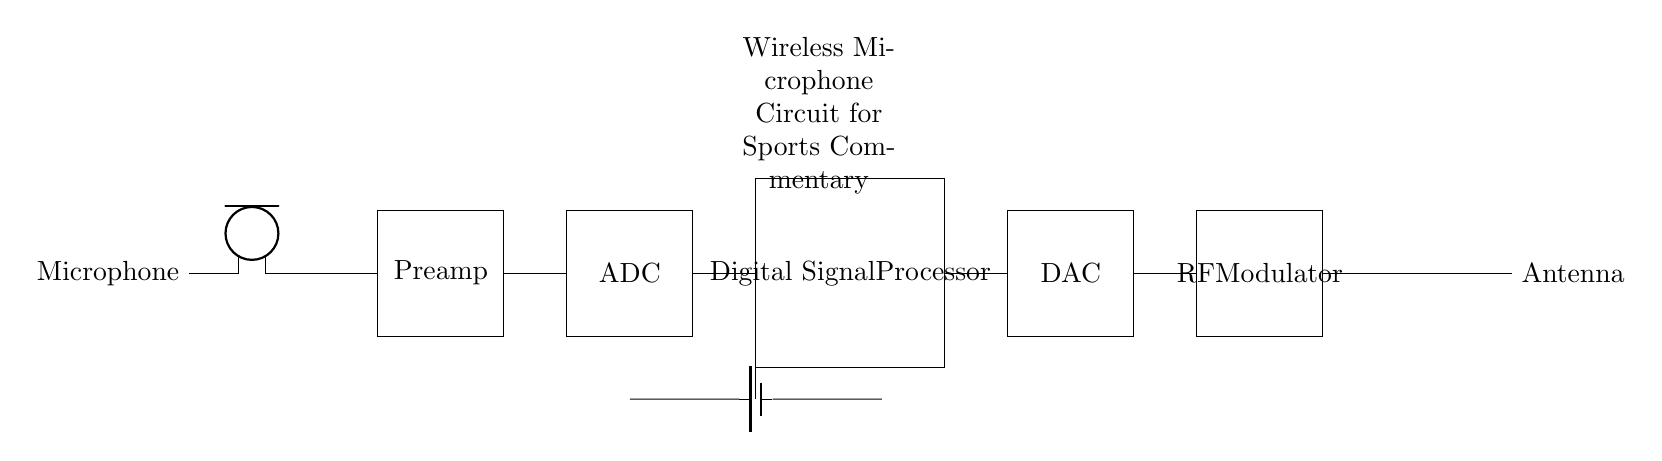What is the first component in the circuit? The first component is the microphone, as it is located at the very beginning of the connection chain, indicating it captures sound.
Answer: Microphone What does the preamp do? The preamp amplifies the weak audio signal from the microphone before it is processed further; it is denoted as a block in the diagram.
Answer: Amplifies How many main processing components are in this circuit? There are four main processing components: Preamp, ADC, Digital Signal Processor, and DAC.
Answer: Four Which component converts analog signals to digital? The ADC (Analog to Digital Converter) is responsible for converting the analog audio signals into digital format for processing.
Answer: ADC What is the purpose of the RF modulator? The RF modulator converts the processed digital signals into radio frequency signals for wireless transmission, indicated by its placement in the circuit.
Answer: Wireless transmission What component is directly connected to the power supply? The Digital Signal Processor is directly connected to the power supply which provides the necessary voltage for operation, as illustrated in the circuit.
Answer: Digital Signal Processor Which component is responsible for sending the signal out? The antenna is responsible for sending the modulated signals out into the air for reception, as the last component in the circuit indicates this function.
Answer: Antenna 